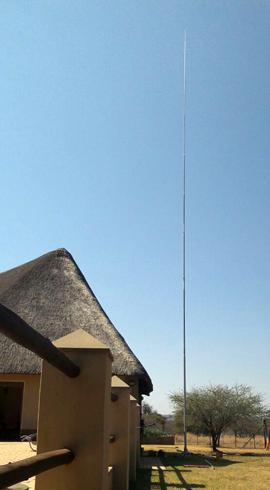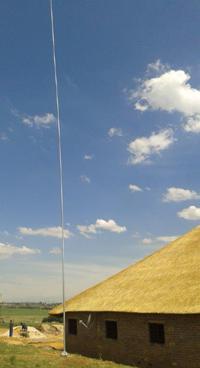The first image is the image on the left, the second image is the image on the right. Examine the images to the left and right. Is the description "The left and right image contains the same number of of poles to the to one side of the house." accurate? Answer yes or no. Yes. The first image is the image on the left, the second image is the image on the right. Given the left and right images, does the statement "One of the houses has at least one chimney." hold true? Answer yes or no. No. 